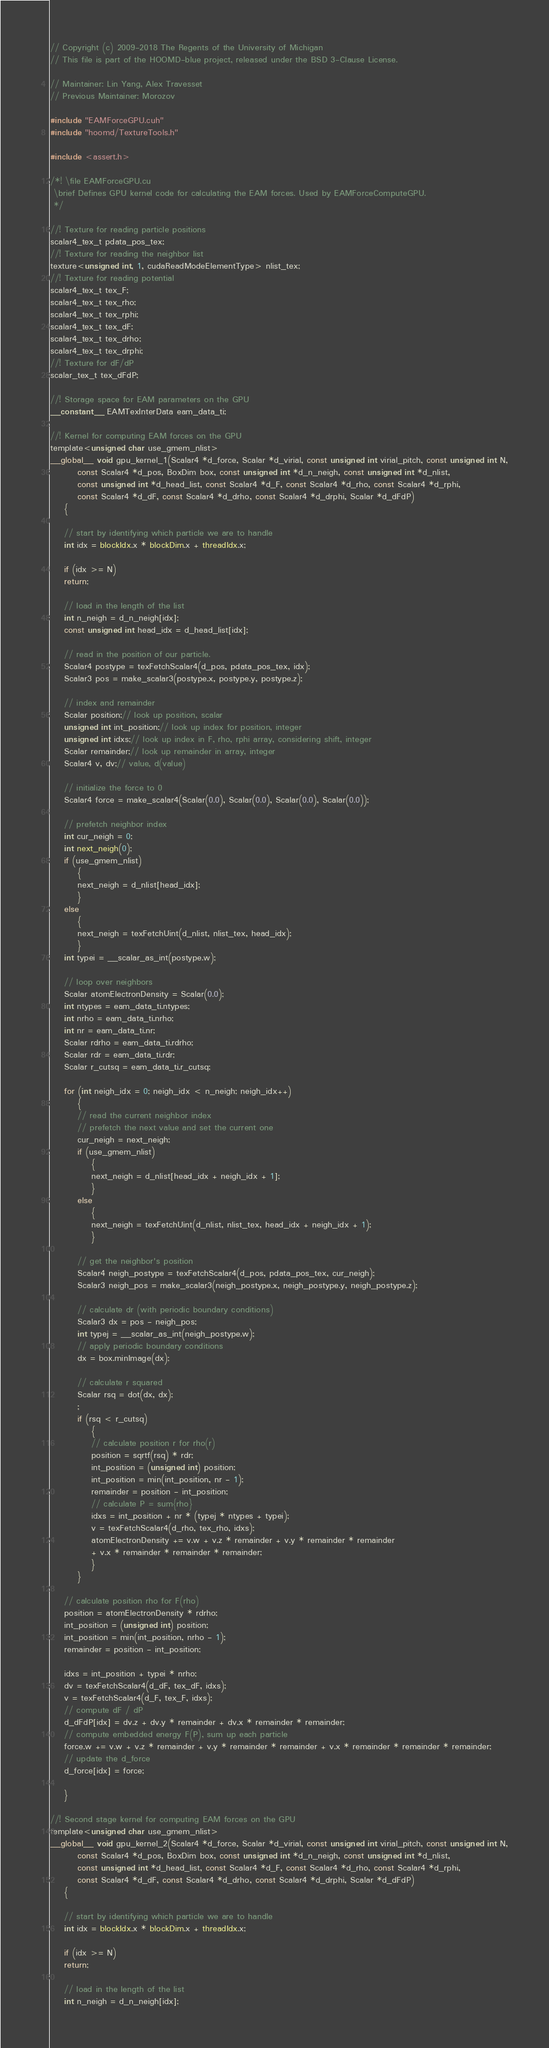<code> <loc_0><loc_0><loc_500><loc_500><_Cuda_>// Copyright (c) 2009-2018 The Regents of the University of Michigan
// This file is part of the HOOMD-blue project, released under the BSD 3-Clause License.

// Maintainer: Lin Yang, Alex Travesset
// Previous Maintainer: Morozov

#include "EAMForceGPU.cuh"
#include "hoomd/TextureTools.h"

#include <assert.h>

/*! \file EAMForceGPU.cu
 \brief Defines GPU kernel code for calculating the EAM forces. Used by EAMForceComputeGPU.
 */

//! Texture for reading particle positions
scalar4_tex_t pdata_pos_tex;
//! Texture for reading the neighbor list
texture<unsigned int, 1, cudaReadModeElementType> nlist_tex;
//! Texture for reading potential
scalar4_tex_t tex_F;
scalar4_tex_t tex_rho;
scalar4_tex_t tex_rphi;
scalar4_tex_t tex_dF;
scalar4_tex_t tex_drho;
scalar4_tex_t tex_drphi;
//! Texture for dF/dP
scalar_tex_t tex_dFdP;

//! Storage space for EAM parameters on the GPU
__constant__ EAMTexInterData eam_data_ti;

//! Kernel for computing EAM forces on the GPU
template<unsigned char use_gmem_nlist>
__global__ void gpu_kernel_1(Scalar4 *d_force, Scalar *d_virial, const unsigned int virial_pitch, const unsigned int N,
        const Scalar4 *d_pos, BoxDim box, const unsigned int *d_n_neigh, const unsigned int *d_nlist,
        const unsigned int *d_head_list, const Scalar4 *d_F, const Scalar4 *d_rho, const Scalar4 *d_rphi,
        const Scalar4 *d_dF, const Scalar4 *d_drho, const Scalar4 *d_drphi, Scalar *d_dFdP)
    {

    // start by identifying which particle we are to handle
    int idx = blockIdx.x * blockDim.x + threadIdx.x;

    if (idx >= N)
    return;

    // load in the length of the list
    int n_neigh = d_n_neigh[idx];
    const unsigned int head_idx = d_head_list[idx];

    // read in the position of our particle.
    Scalar4 postype = texFetchScalar4(d_pos, pdata_pos_tex, idx);
    Scalar3 pos = make_scalar3(postype.x, postype.y, postype.z);

    // index and remainder
    Scalar position;// look up position, scalar
    unsigned int int_position;// look up index for position, integer
    unsigned int idxs;// look up index in F, rho, rphi array, considering shift, integer
    Scalar remainder;// look up remainder in array, integer
    Scalar4 v, dv;// value, d(value)

    // initialize the force to 0
    Scalar4 force = make_scalar4(Scalar(0.0), Scalar(0.0), Scalar(0.0), Scalar(0.0));

    // prefetch neighbor index
    int cur_neigh = 0;
    int next_neigh(0);
    if (use_gmem_nlist)
        {
        next_neigh = d_nlist[head_idx];
        }
    else
        {
        next_neigh = texFetchUint(d_nlist, nlist_tex, head_idx);
        }
    int typei = __scalar_as_int(postype.w);

    // loop over neighbors
    Scalar atomElectronDensity = Scalar(0.0);
    int ntypes = eam_data_ti.ntypes;
    int nrho = eam_data_ti.nrho;
    int nr = eam_data_ti.nr;
    Scalar rdrho = eam_data_ti.rdrho;
    Scalar rdr = eam_data_ti.rdr;
    Scalar r_cutsq = eam_data_ti.r_cutsq;

    for (int neigh_idx = 0; neigh_idx < n_neigh; neigh_idx++)
        {
        // read the current neighbor index
        // prefetch the next value and set the current one
        cur_neigh = next_neigh;
        if (use_gmem_nlist)
            {
            next_neigh = d_nlist[head_idx + neigh_idx + 1];
            }
        else
            {
            next_neigh = texFetchUint(d_nlist, nlist_tex, head_idx + neigh_idx + 1);
            }

        // get the neighbor's position
        Scalar4 neigh_postype = texFetchScalar4(d_pos, pdata_pos_tex, cur_neigh);
        Scalar3 neigh_pos = make_scalar3(neigh_postype.x, neigh_postype.y, neigh_postype.z);

        // calculate dr (with periodic boundary conditions)
        Scalar3 dx = pos - neigh_pos;
        int typej = __scalar_as_int(neigh_postype.w);
        // apply periodic boundary conditions
        dx = box.minImage(dx);

        // calculate r squared
        Scalar rsq = dot(dx, dx);
        ;
        if (rsq < r_cutsq)
            {
            // calculate position r for rho(r)
            position = sqrtf(rsq) * rdr;
            int_position = (unsigned int) position;
            int_position = min(int_position, nr - 1);
            remainder = position - int_position;
            // calculate P = sum{rho}
            idxs = int_position + nr * (typej * ntypes + typei);
            v = texFetchScalar4(d_rho, tex_rho, idxs);
            atomElectronDensity += v.w + v.z * remainder + v.y * remainder * remainder
            + v.x * remainder * remainder * remainder;
            }
        }

    // calculate position rho for F(rho)
    position = atomElectronDensity * rdrho;
    int_position = (unsigned int) position;
    int_position = min(int_position, nrho - 1);
    remainder = position - int_position;

    idxs = int_position + typei * nrho;
    dv = texFetchScalar4(d_dF, tex_dF, idxs);
    v = texFetchScalar4(d_F, tex_F, idxs);
    // compute dF / dP
    d_dFdP[idx] = dv.z + dv.y * remainder + dv.x * remainder * remainder;
    // compute embedded energy F(P), sum up each particle
    force.w += v.w + v.z * remainder + v.y * remainder * remainder + v.x * remainder * remainder * remainder;
    // update the d_force
    d_force[idx] = force;

    }

//! Second stage kernel for computing EAM forces on the GPU
template<unsigned char use_gmem_nlist>
__global__ void gpu_kernel_2(Scalar4 *d_force, Scalar *d_virial, const unsigned int virial_pitch, const unsigned int N,
        const Scalar4 *d_pos, BoxDim box, const unsigned int *d_n_neigh, const unsigned int *d_nlist,
        const unsigned int *d_head_list, const Scalar4 *d_F, const Scalar4 *d_rho, const Scalar4 *d_rphi,
        const Scalar4 *d_dF, const Scalar4 *d_drho, const Scalar4 *d_drphi, Scalar *d_dFdP)
    {

    // start by identifying which particle we are to handle
    int idx = blockIdx.x * blockDim.x + threadIdx.x;

    if (idx >= N)
    return;

    // load in the length of the list
    int n_neigh = d_n_neigh[idx];</code> 